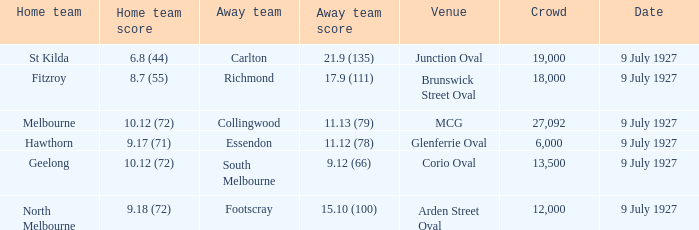Who was the away team playing the home team North Melbourne? Footscray. 